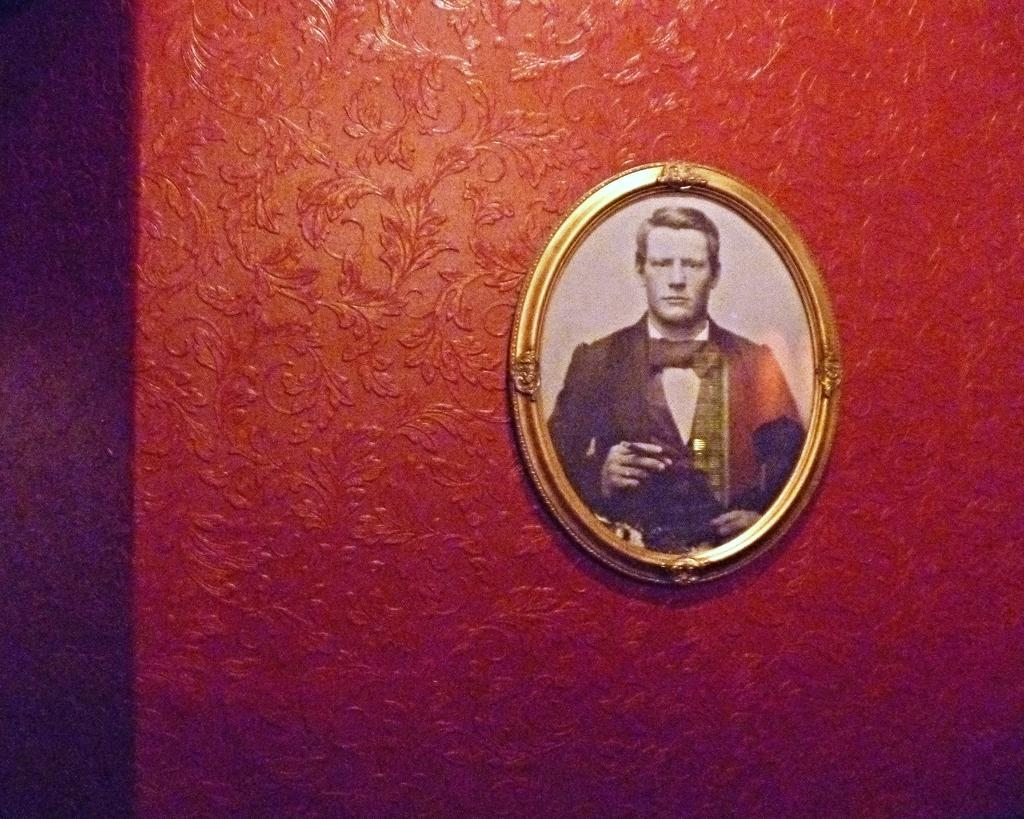What is present on the wall in the image? There is a picture frame on the wall in the image. What color is the wall in the image? The wall is red in color. What can be seen inside the picture frame? There is a picture of a man in the picture frame. What type of furniture is present in the image? There is no furniture present in the image; it only features a wall with a picture frame. How does the earth contribute to the image? The image does not depict the earth or any related elements. 